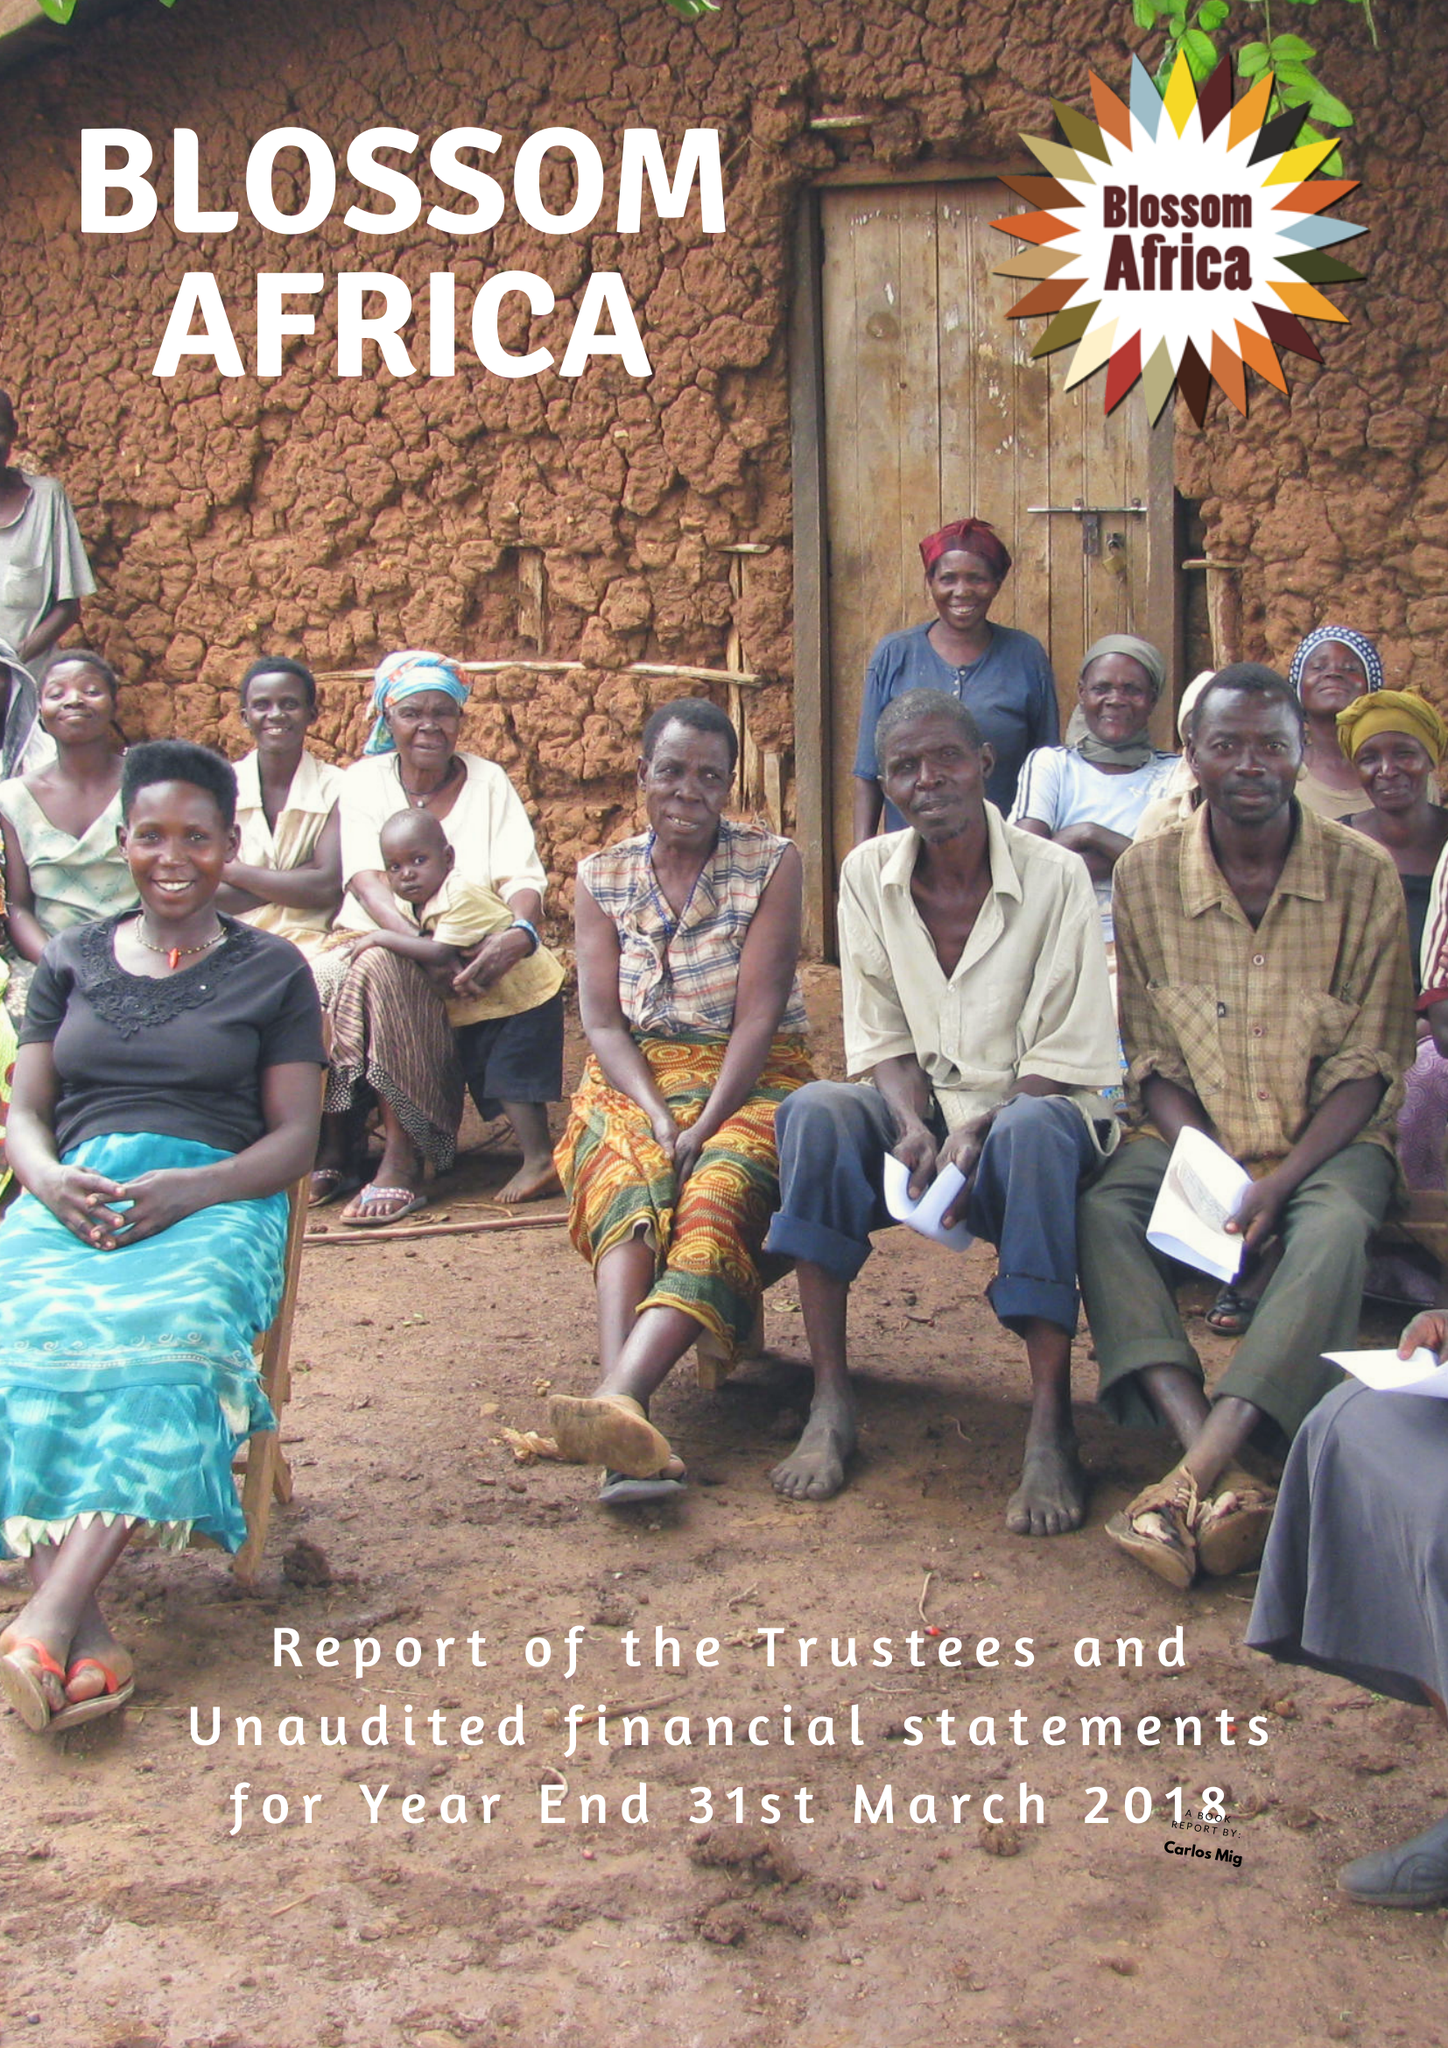What is the value for the income_annually_in_british_pounds?
Answer the question using a single word or phrase. 3257.00 